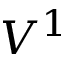Convert formula to latex. <formula><loc_0><loc_0><loc_500><loc_500>V ^ { 1 }</formula> 